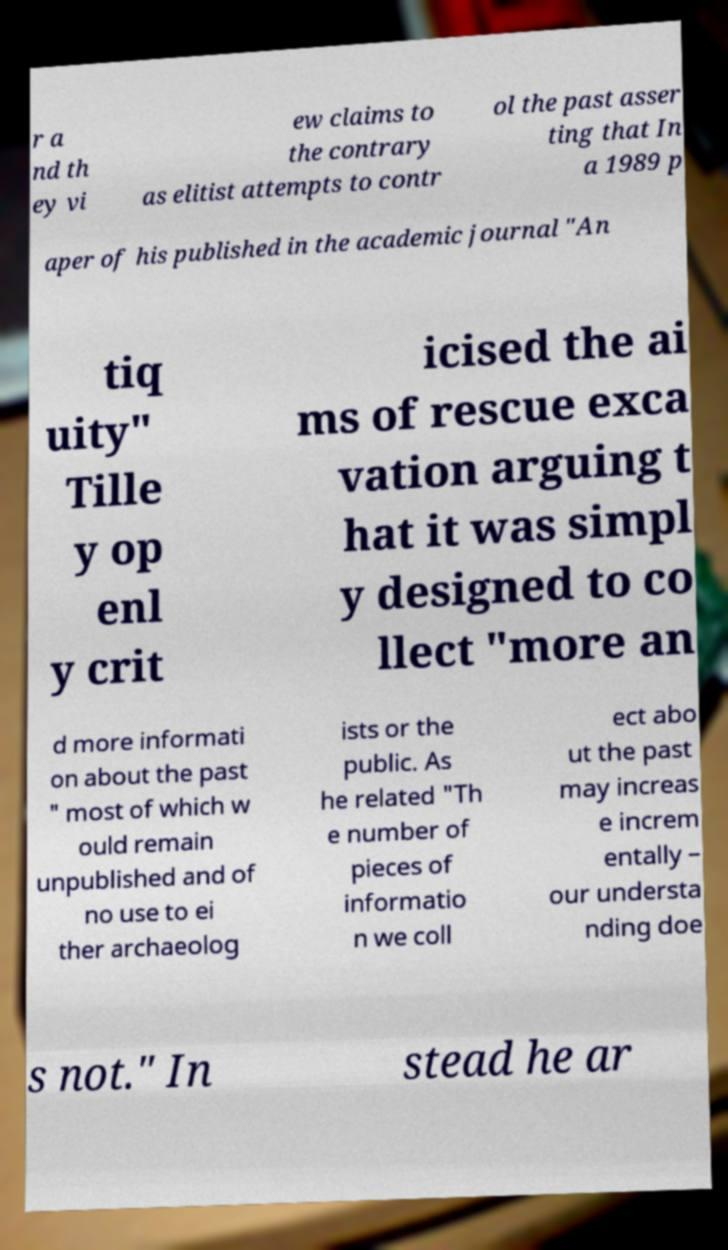Could you assist in decoding the text presented in this image and type it out clearly? r a nd th ey vi ew claims to the contrary as elitist attempts to contr ol the past asser ting that In a 1989 p aper of his published in the academic journal "An tiq uity" Tille y op enl y crit icised the ai ms of rescue exca vation arguing t hat it was simpl y designed to co llect "more an d more informati on about the past " most of which w ould remain unpublished and of no use to ei ther archaeolog ists or the public. As he related "Th e number of pieces of informatio n we coll ect abo ut the past may increas e increm entally – our understa nding doe s not." In stead he ar 